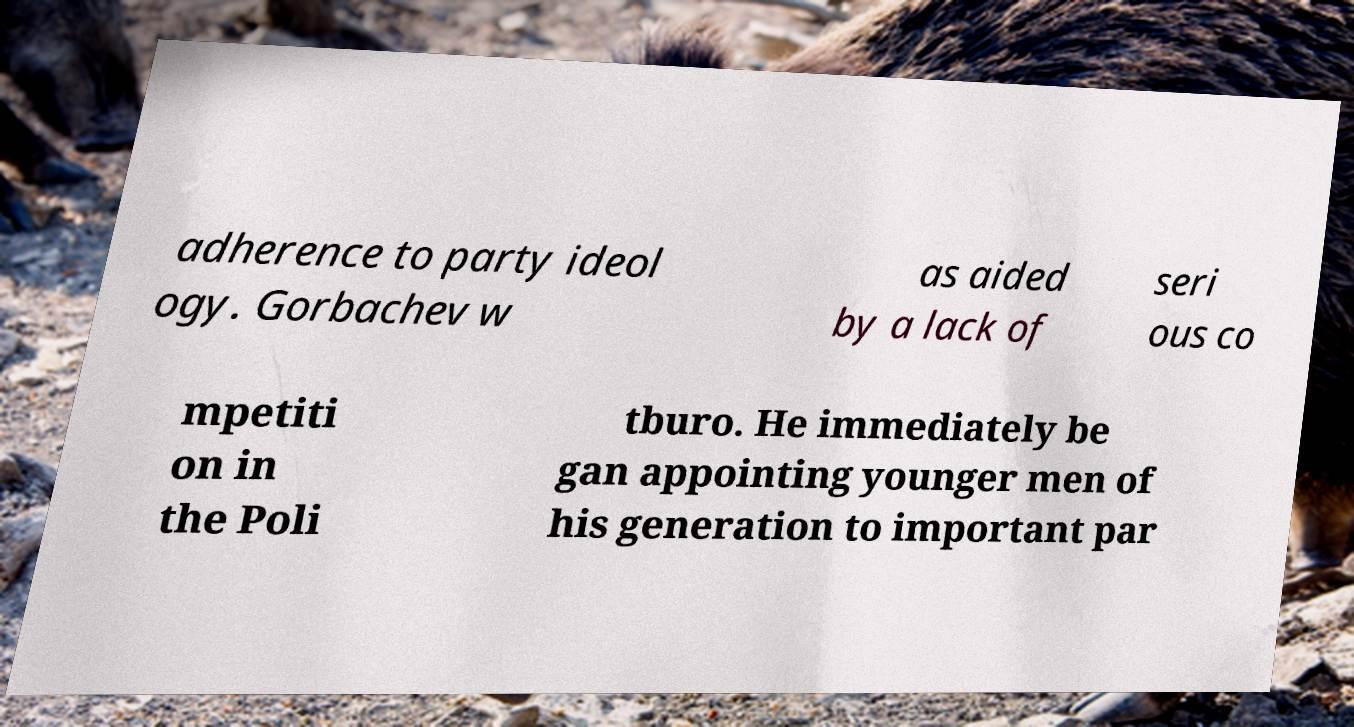There's text embedded in this image that I need extracted. Can you transcribe it verbatim? adherence to party ideol ogy. Gorbachev w as aided by a lack of seri ous co mpetiti on in the Poli tburo. He immediately be gan appointing younger men of his generation to important par 